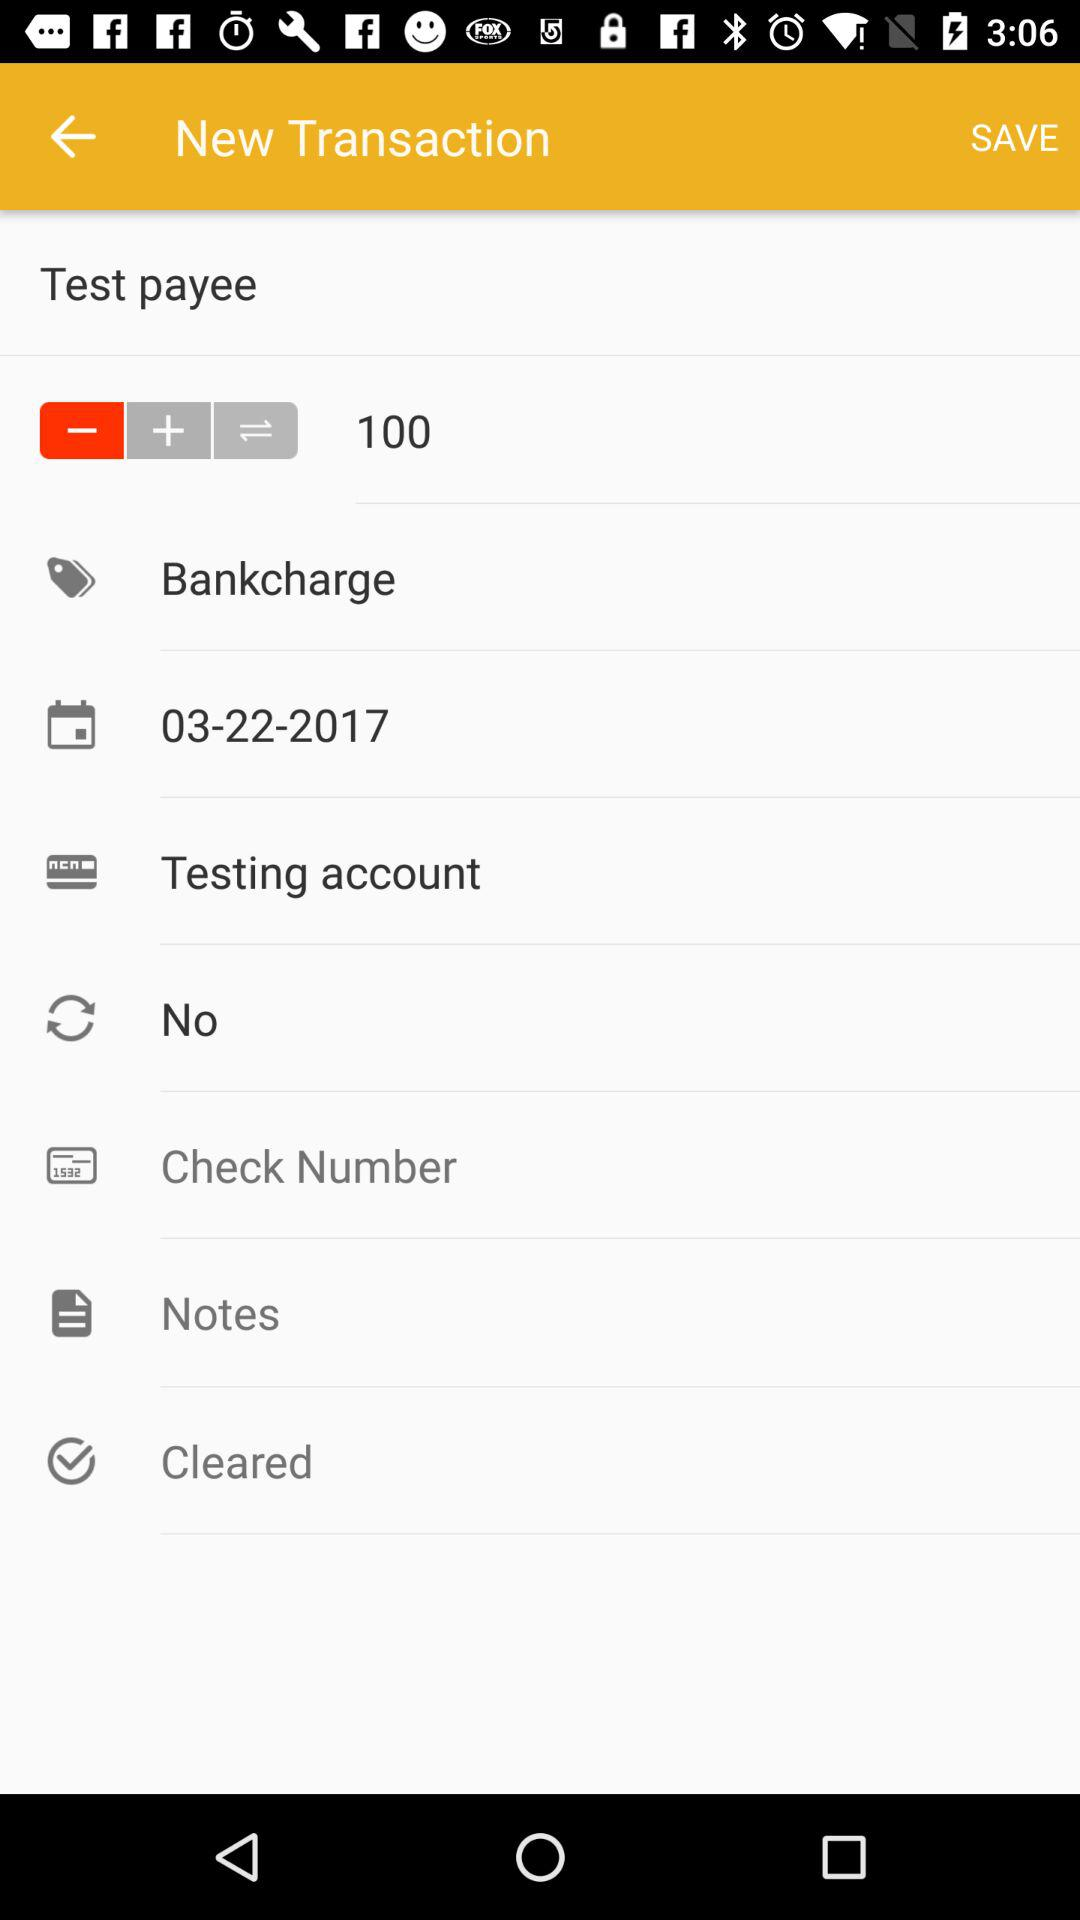How many test payee are there?
When the provided information is insufficient, respond with <no answer>. <no answer> 